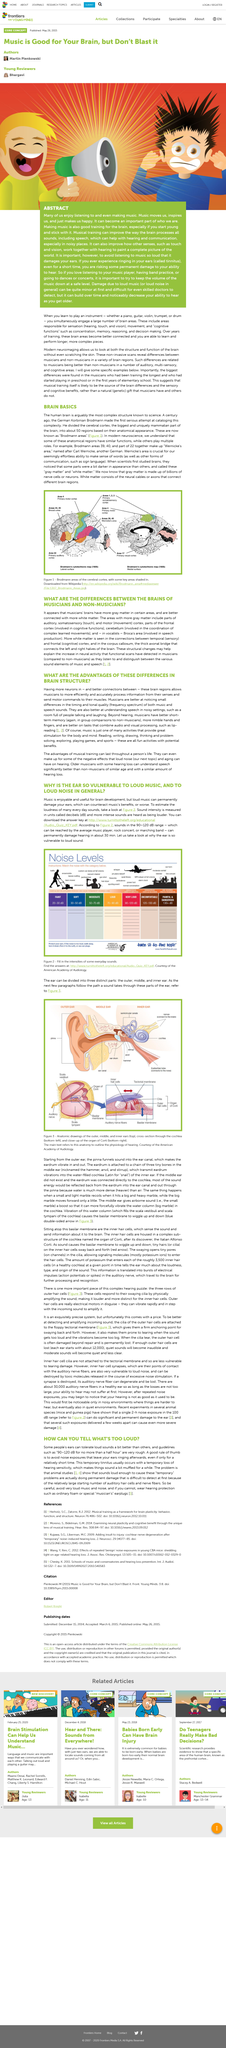Mention a couple of crucial points in this snapshot. The human brain is arguably the most complex structure known to science. Yes, musicians have more neurons than non-musicians. The ear is vulnerable to loud music. Yes, musicians have brain structures that allow them to better understand speech in noisy settings. Areas 44 and 45 are commonly referred to as "Broca's Area. 